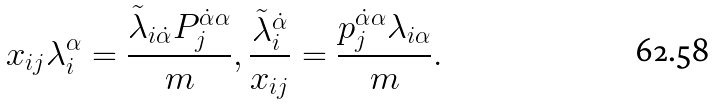Convert formula to latex. <formula><loc_0><loc_0><loc_500><loc_500>x _ { i j } \lambda _ { i } ^ { \alpha } = \frac { \tilde { \lambda } _ { i \dot { \alpha } } P ^ { \dot { \alpha } \alpha } _ { j } } { m } , \frac { \tilde { \lambda } _ { i } ^ { \dot { \alpha } } } { x _ { i j } } = \frac { p _ { j } ^ { \dot { \alpha } \alpha } \lambda _ { i \alpha } } { m } .</formula> 